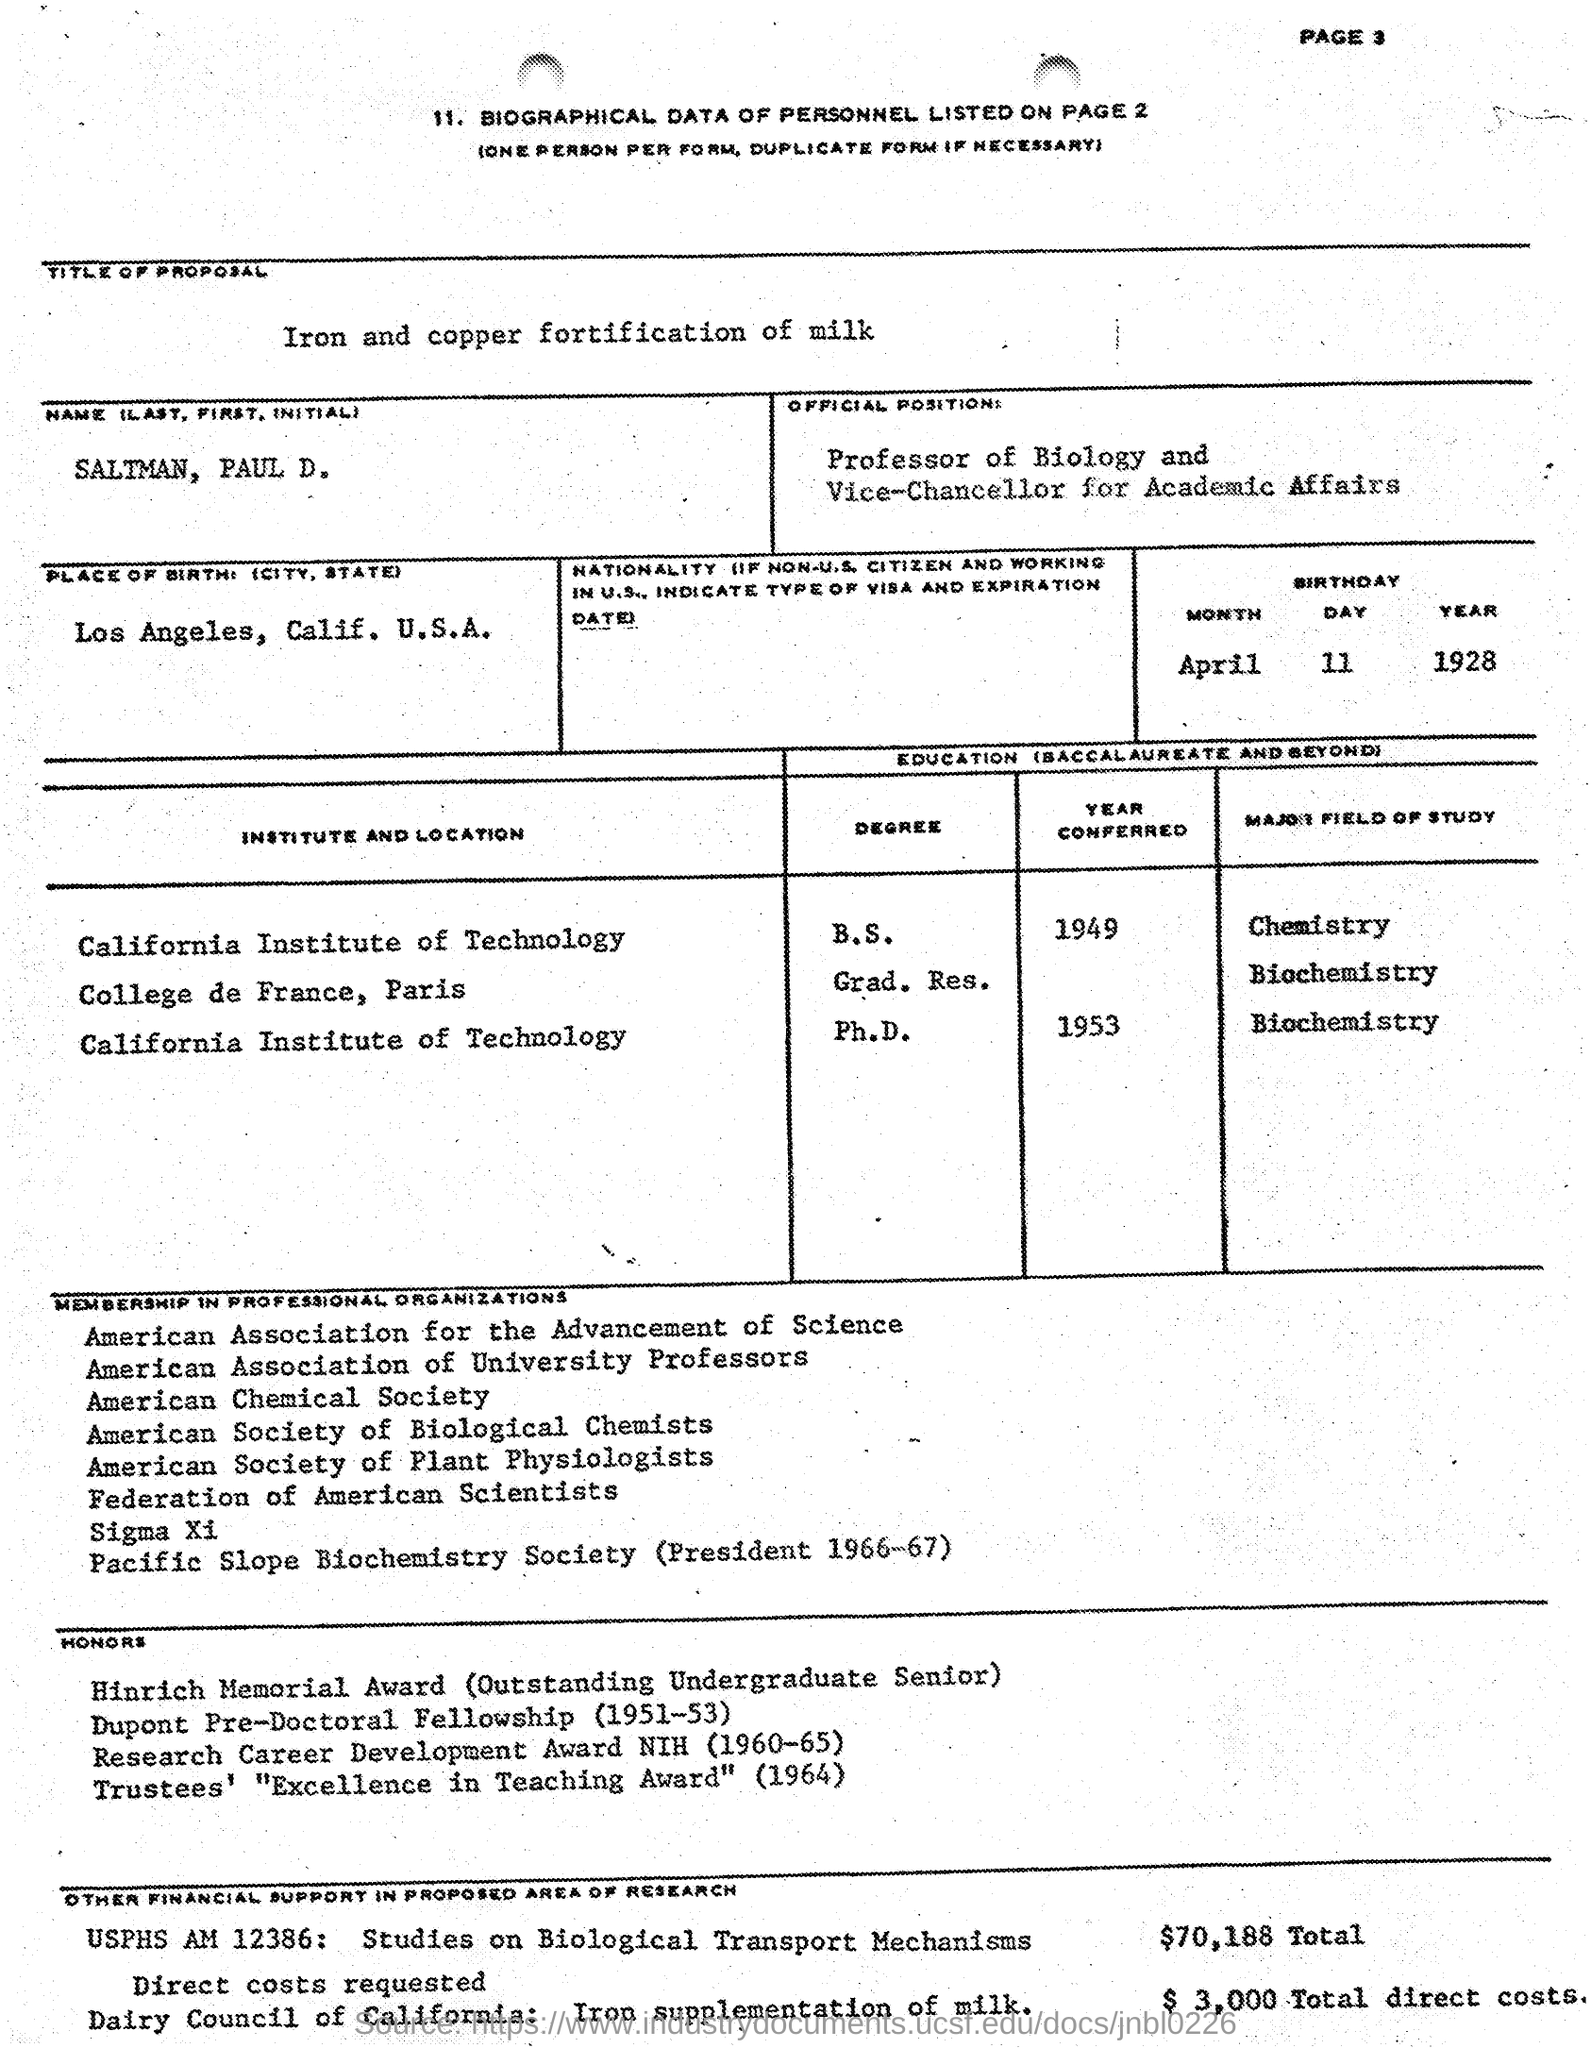Outline some significant characteristics in this image. Paul D. Saltman obtained his Ph.D. in Biochemistry from the California Institute of Technology. SALTMAN, PAUL D. was born on APRIL 11 1928. Paul D. Saltman completed his Bachelor of Science degree in Chemistry from the California Institute of Technology in 1949. In the year 1964, Paul D. Saltman won the Trustees' Excellence in Teaching Award. The title of the proposal presented in the document is "Iron and Copper Fortification of Milk. 